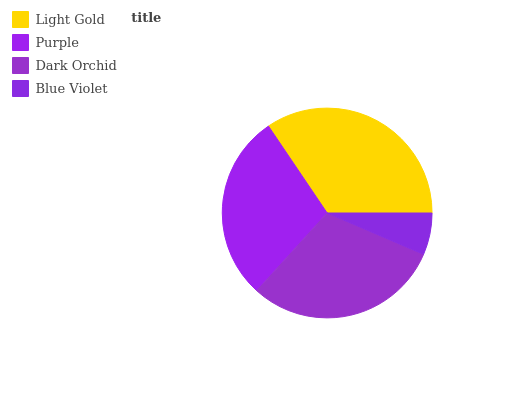Is Blue Violet the minimum?
Answer yes or no. Yes. Is Light Gold the maximum?
Answer yes or no. Yes. Is Purple the minimum?
Answer yes or no. No. Is Purple the maximum?
Answer yes or no. No. Is Light Gold greater than Purple?
Answer yes or no. Yes. Is Purple less than Light Gold?
Answer yes or no. Yes. Is Purple greater than Light Gold?
Answer yes or no. No. Is Light Gold less than Purple?
Answer yes or no. No. Is Dark Orchid the high median?
Answer yes or no. Yes. Is Purple the low median?
Answer yes or no. Yes. Is Purple the high median?
Answer yes or no. No. Is Dark Orchid the low median?
Answer yes or no. No. 